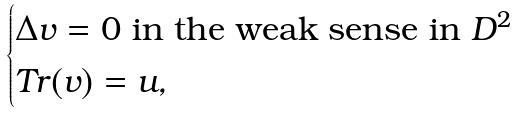Convert formula to latex. <formula><loc_0><loc_0><loc_500><loc_500>\begin{cases} \Delta v = 0 \text { in the weak sense in } D ^ { 2 } \\ T r ( v ) = u , \end{cases}</formula> 